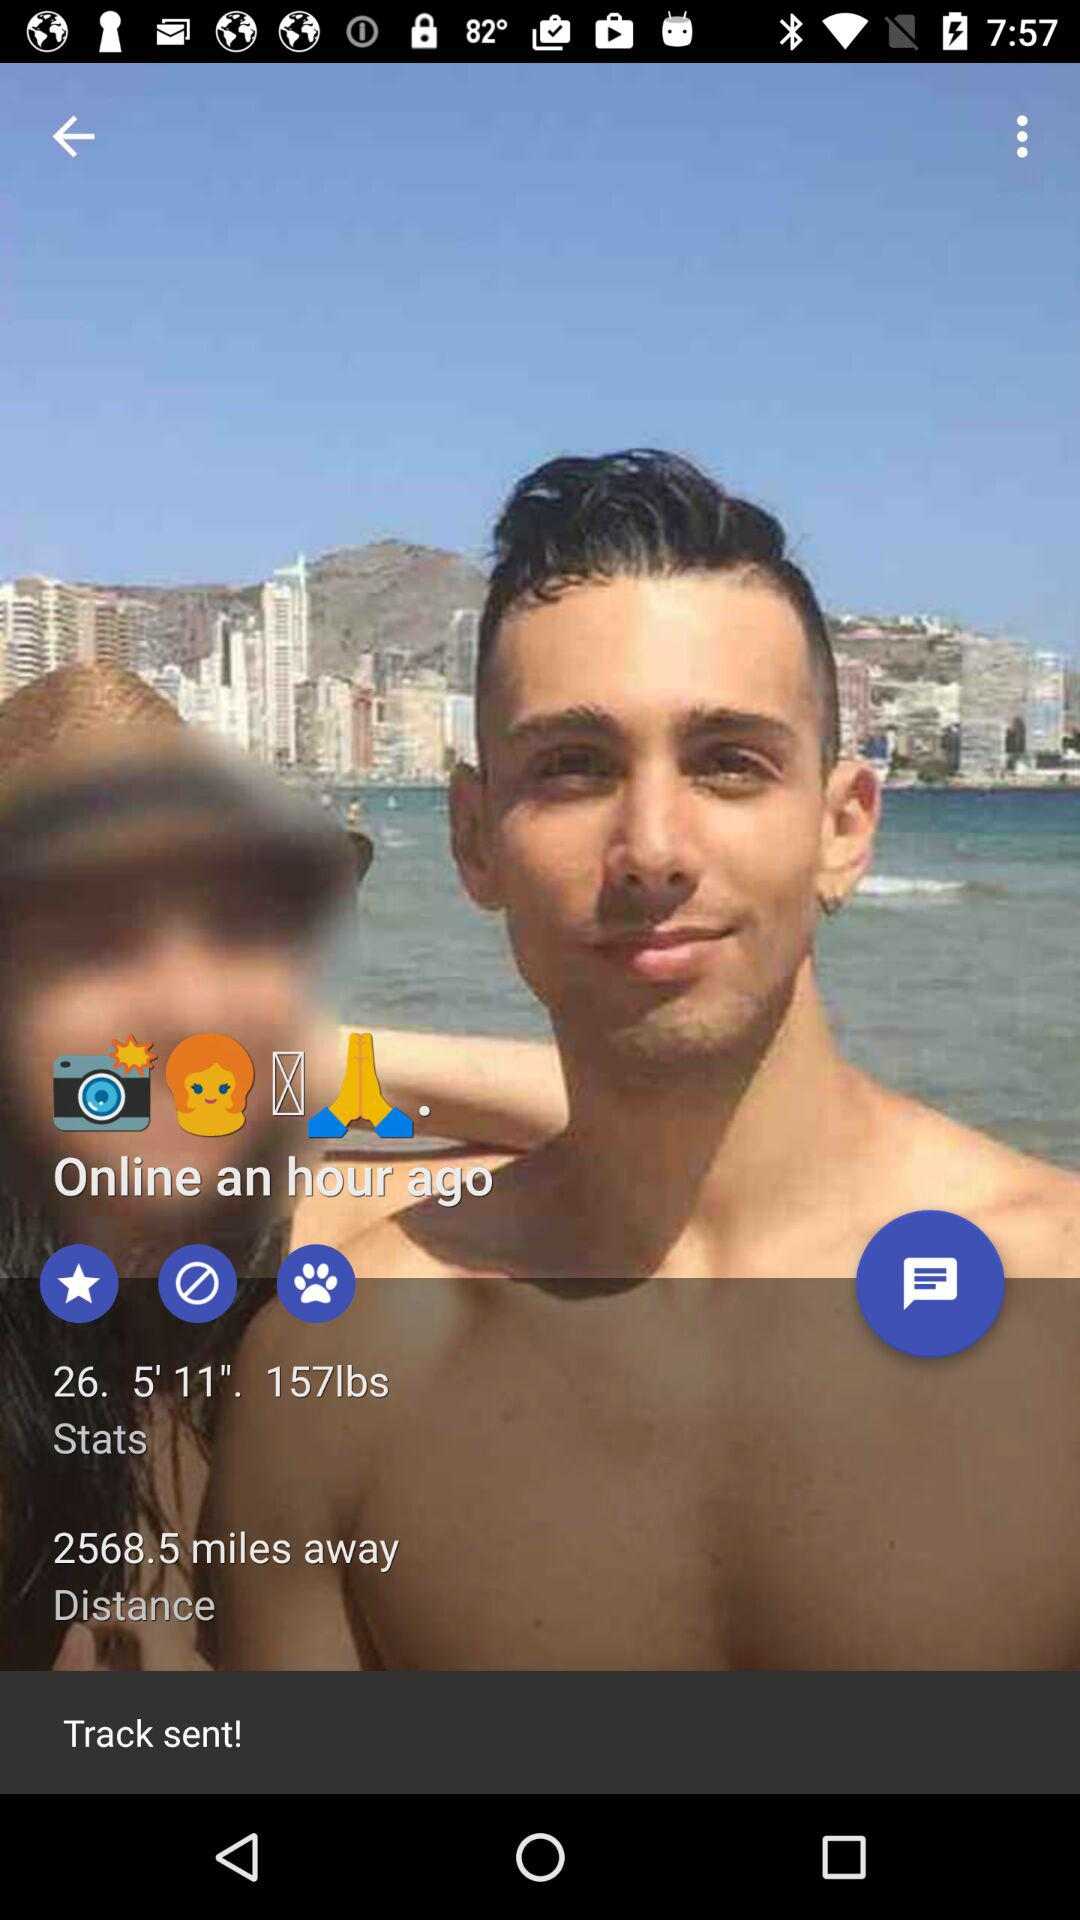When did the person last go online? The person was online an hour ago. 